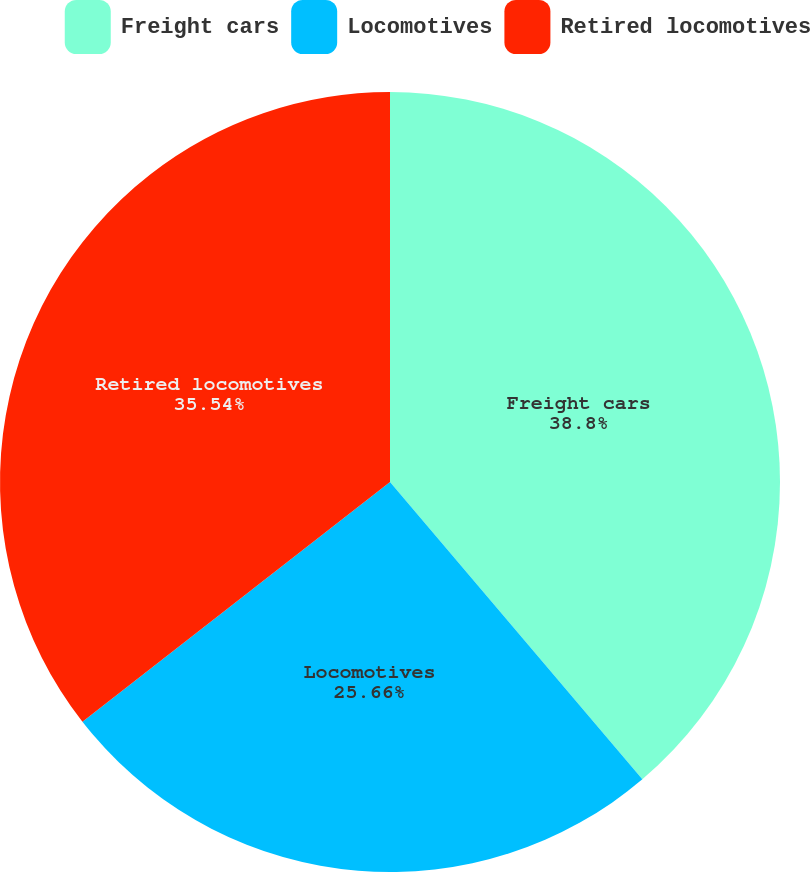Convert chart to OTSL. <chart><loc_0><loc_0><loc_500><loc_500><pie_chart><fcel>Freight cars<fcel>Locomotives<fcel>Retired locomotives<nl><fcel>38.8%<fcel>25.66%<fcel>35.54%<nl></chart> 